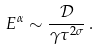Convert formula to latex. <formula><loc_0><loc_0><loc_500><loc_500>E ^ { \alpha } \sim \frac { \mathcal { D } } { \gamma \tau ^ { 2 \sigma } } \, .</formula> 